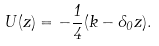<formula> <loc_0><loc_0><loc_500><loc_500>U ( z ) = - \frac { 1 } { 4 } ( k - \Lambda _ { 0 } z ) .</formula> 